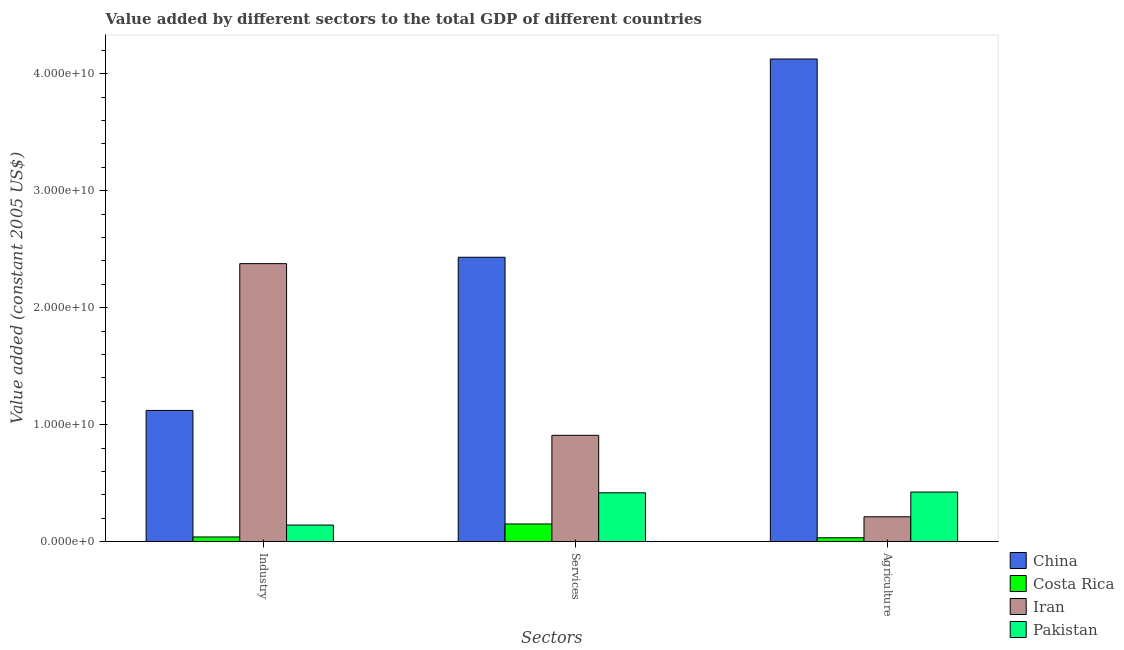How many different coloured bars are there?
Your answer should be compact. 4. How many groups of bars are there?
Offer a very short reply. 3. Are the number of bars on each tick of the X-axis equal?
Provide a succinct answer. Yes. How many bars are there on the 1st tick from the left?
Keep it short and to the point. 4. What is the label of the 1st group of bars from the left?
Offer a terse response. Industry. What is the value added by industrial sector in Costa Rica?
Your answer should be very brief. 3.94e+08. Across all countries, what is the maximum value added by industrial sector?
Make the answer very short. 2.38e+1. Across all countries, what is the minimum value added by agricultural sector?
Keep it short and to the point. 3.24e+08. In which country was the value added by industrial sector minimum?
Make the answer very short. Costa Rica. What is the total value added by services in the graph?
Your answer should be compact. 3.91e+1. What is the difference between the value added by industrial sector in Costa Rica and that in China?
Offer a very short reply. -1.08e+1. What is the difference between the value added by services in Pakistan and the value added by industrial sector in Costa Rica?
Your response must be concise. 3.78e+09. What is the average value added by industrial sector per country?
Provide a short and direct response. 9.20e+09. What is the difference between the value added by services and value added by industrial sector in Pakistan?
Offer a terse response. 2.76e+09. What is the ratio of the value added by services in Costa Rica to that in China?
Give a very brief answer. 0.06. What is the difference between the highest and the second highest value added by agricultural sector?
Provide a short and direct response. 3.70e+1. What is the difference between the highest and the lowest value added by services?
Your response must be concise. 2.28e+1. In how many countries, is the value added by industrial sector greater than the average value added by industrial sector taken over all countries?
Ensure brevity in your answer.  2. What does the 3rd bar from the left in Services represents?
Make the answer very short. Iran. What does the 2nd bar from the right in Industry represents?
Your answer should be compact. Iran. Are all the bars in the graph horizontal?
Ensure brevity in your answer.  No. How many countries are there in the graph?
Offer a very short reply. 4. Are the values on the major ticks of Y-axis written in scientific E-notation?
Your answer should be compact. Yes. Does the graph contain any zero values?
Keep it short and to the point. No. Does the graph contain grids?
Your answer should be very brief. No. How many legend labels are there?
Make the answer very short. 4. What is the title of the graph?
Offer a very short reply. Value added by different sectors to the total GDP of different countries. Does "Poland" appear as one of the legend labels in the graph?
Your answer should be compact. No. What is the label or title of the X-axis?
Keep it short and to the point. Sectors. What is the label or title of the Y-axis?
Keep it short and to the point. Value added (constant 2005 US$). What is the Value added (constant 2005 US$) in China in Industry?
Make the answer very short. 1.12e+1. What is the Value added (constant 2005 US$) in Costa Rica in Industry?
Give a very brief answer. 3.94e+08. What is the Value added (constant 2005 US$) in Iran in Industry?
Give a very brief answer. 2.38e+1. What is the Value added (constant 2005 US$) of Pakistan in Industry?
Make the answer very short. 1.41e+09. What is the Value added (constant 2005 US$) of China in Services?
Provide a succinct answer. 2.43e+1. What is the Value added (constant 2005 US$) of Costa Rica in Services?
Provide a succinct answer. 1.51e+09. What is the Value added (constant 2005 US$) in Iran in Services?
Your answer should be very brief. 9.09e+09. What is the Value added (constant 2005 US$) in Pakistan in Services?
Ensure brevity in your answer.  4.17e+09. What is the Value added (constant 2005 US$) of China in Agriculture?
Your answer should be very brief. 4.13e+1. What is the Value added (constant 2005 US$) of Costa Rica in Agriculture?
Offer a very short reply. 3.24e+08. What is the Value added (constant 2005 US$) in Iran in Agriculture?
Provide a short and direct response. 2.12e+09. What is the Value added (constant 2005 US$) in Pakistan in Agriculture?
Offer a terse response. 4.23e+09. Across all Sectors, what is the maximum Value added (constant 2005 US$) in China?
Give a very brief answer. 4.13e+1. Across all Sectors, what is the maximum Value added (constant 2005 US$) in Costa Rica?
Ensure brevity in your answer.  1.51e+09. Across all Sectors, what is the maximum Value added (constant 2005 US$) of Iran?
Keep it short and to the point. 2.38e+1. Across all Sectors, what is the maximum Value added (constant 2005 US$) of Pakistan?
Keep it short and to the point. 4.23e+09. Across all Sectors, what is the minimum Value added (constant 2005 US$) in China?
Make the answer very short. 1.12e+1. Across all Sectors, what is the minimum Value added (constant 2005 US$) in Costa Rica?
Your answer should be compact. 3.24e+08. Across all Sectors, what is the minimum Value added (constant 2005 US$) of Iran?
Provide a succinct answer. 2.12e+09. Across all Sectors, what is the minimum Value added (constant 2005 US$) of Pakistan?
Provide a short and direct response. 1.41e+09. What is the total Value added (constant 2005 US$) of China in the graph?
Ensure brevity in your answer.  7.68e+1. What is the total Value added (constant 2005 US$) in Costa Rica in the graph?
Give a very brief answer. 2.22e+09. What is the total Value added (constant 2005 US$) in Iran in the graph?
Offer a terse response. 3.50e+1. What is the total Value added (constant 2005 US$) in Pakistan in the graph?
Ensure brevity in your answer.  9.82e+09. What is the difference between the Value added (constant 2005 US$) in China in Industry and that in Services?
Offer a very short reply. -1.31e+1. What is the difference between the Value added (constant 2005 US$) in Costa Rica in Industry and that in Services?
Offer a terse response. -1.11e+09. What is the difference between the Value added (constant 2005 US$) in Iran in Industry and that in Services?
Ensure brevity in your answer.  1.47e+1. What is the difference between the Value added (constant 2005 US$) in Pakistan in Industry and that in Services?
Offer a terse response. -2.76e+09. What is the difference between the Value added (constant 2005 US$) of China in Industry and that in Agriculture?
Give a very brief answer. -3.01e+1. What is the difference between the Value added (constant 2005 US$) of Costa Rica in Industry and that in Agriculture?
Provide a short and direct response. 6.91e+07. What is the difference between the Value added (constant 2005 US$) in Iran in Industry and that in Agriculture?
Give a very brief answer. 2.16e+1. What is the difference between the Value added (constant 2005 US$) of Pakistan in Industry and that in Agriculture?
Make the answer very short. -2.82e+09. What is the difference between the Value added (constant 2005 US$) of China in Services and that in Agriculture?
Your response must be concise. -1.70e+1. What is the difference between the Value added (constant 2005 US$) in Costa Rica in Services and that in Agriculture?
Provide a short and direct response. 1.18e+09. What is the difference between the Value added (constant 2005 US$) of Iran in Services and that in Agriculture?
Offer a terse response. 6.97e+09. What is the difference between the Value added (constant 2005 US$) in Pakistan in Services and that in Agriculture?
Your response must be concise. -6.35e+07. What is the difference between the Value added (constant 2005 US$) in China in Industry and the Value added (constant 2005 US$) in Costa Rica in Services?
Keep it short and to the point. 9.71e+09. What is the difference between the Value added (constant 2005 US$) in China in Industry and the Value added (constant 2005 US$) in Iran in Services?
Provide a succinct answer. 2.13e+09. What is the difference between the Value added (constant 2005 US$) of China in Industry and the Value added (constant 2005 US$) of Pakistan in Services?
Your answer should be compact. 7.04e+09. What is the difference between the Value added (constant 2005 US$) in Costa Rica in Industry and the Value added (constant 2005 US$) in Iran in Services?
Offer a very short reply. -8.69e+09. What is the difference between the Value added (constant 2005 US$) in Costa Rica in Industry and the Value added (constant 2005 US$) in Pakistan in Services?
Your response must be concise. -3.78e+09. What is the difference between the Value added (constant 2005 US$) in Iran in Industry and the Value added (constant 2005 US$) in Pakistan in Services?
Make the answer very short. 1.96e+1. What is the difference between the Value added (constant 2005 US$) of China in Industry and the Value added (constant 2005 US$) of Costa Rica in Agriculture?
Provide a succinct answer. 1.09e+1. What is the difference between the Value added (constant 2005 US$) in China in Industry and the Value added (constant 2005 US$) in Iran in Agriculture?
Offer a terse response. 9.09e+09. What is the difference between the Value added (constant 2005 US$) in China in Industry and the Value added (constant 2005 US$) in Pakistan in Agriculture?
Your answer should be compact. 6.98e+09. What is the difference between the Value added (constant 2005 US$) of Costa Rica in Industry and the Value added (constant 2005 US$) of Iran in Agriculture?
Provide a short and direct response. -1.73e+09. What is the difference between the Value added (constant 2005 US$) of Costa Rica in Industry and the Value added (constant 2005 US$) of Pakistan in Agriculture?
Your answer should be compact. -3.84e+09. What is the difference between the Value added (constant 2005 US$) in Iran in Industry and the Value added (constant 2005 US$) in Pakistan in Agriculture?
Give a very brief answer. 1.95e+1. What is the difference between the Value added (constant 2005 US$) of China in Services and the Value added (constant 2005 US$) of Costa Rica in Agriculture?
Your response must be concise. 2.40e+1. What is the difference between the Value added (constant 2005 US$) of China in Services and the Value added (constant 2005 US$) of Iran in Agriculture?
Your answer should be compact. 2.22e+1. What is the difference between the Value added (constant 2005 US$) in China in Services and the Value added (constant 2005 US$) in Pakistan in Agriculture?
Make the answer very short. 2.01e+1. What is the difference between the Value added (constant 2005 US$) of Costa Rica in Services and the Value added (constant 2005 US$) of Iran in Agriculture?
Provide a succinct answer. -6.14e+08. What is the difference between the Value added (constant 2005 US$) of Costa Rica in Services and the Value added (constant 2005 US$) of Pakistan in Agriculture?
Your answer should be very brief. -2.73e+09. What is the difference between the Value added (constant 2005 US$) in Iran in Services and the Value added (constant 2005 US$) in Pakistan in Agriculture?
Provide a succinct answer. 4.85e+09. What is the average Value added (constant 2005 US$) in China per Sectors?
Your answer should be compact. 2.56e+1. What is the average Value added (constant 2005 US$) in Costa Rica per Sectors?
Provide a short and direct response. 7.41e+08. What is the average Value added (constant 2005 US$) in Iran per Sectors?
Make the answer very short. 1.17e+1. What is the average Value added (constant 2005 US$) of Pakistan per Sectors?
Make the answer very short. 3.27e+09. What is the difference between the Value added (constant 2005 US$) in China and Value added (constant 2005 US$) in Costa Rica in Industry?
Keep it short and to the point. 1.08e+1. What is the difference between the Value added (constant 2005 US$) in China and Value added (constant 2005 US$) in Iran in Industry?
Your answer should be very brief. -1.26e+1. What is the difference between the Value added (constant 2005 US$) in China and Value added (constant 2005 US$) in Pakistan in Industry?
Make the answer very short. 9.80e+09. What is the difference between the Value added (constant 2005 US$) in Costa Rica and Value added (constant 2005 US$) in Iran in Industry?
Offer a very short reply. -2.34e+1. What is the difference between the Value added (constant 2005 US$) in Costa Rica and Value added (constant 2005 US$) in Pakistan in Industry?
Make the answer very short. -1.02e+09. What is the difference between the Value added (constant 2005 US$) of Iran and Value added (constant 2005 US$) of Pakistan in Industry?
Your answer should be very brief. 2.24e+1. What is the difference between the Value added (constant 2005 US$) of China and Value added (constant 2005 US$) of Costa Rica in Services?
Provide a succinct answer. 2.28e+1. What is the difference between the Value added (constant 2005 US$) of China and Value added (constant 2005 US$) of Iran in Services?
Offer a very short reply. 1.52e+1. What is the difference between the Value added (constant 2005 US$) of China and Value added (constant 2005 US$) of Pakistan in Services?
Provide a short and direct response. 2.01e+1. What is the difference between the Value added (constant 2005 US$) of Costa Rica and Value added (constant 2005 US$) of Iran in Services?
Your answer should be compact. -7.58e+09. What is the difference between the Value added (constant 2005 US$) in Costa Rica and Value added (constant 2005 US$) in Pakistan in Services?
Your answer should be compact. -2.67e+09. What is the difference between the Value added (constant 2005 US$) of Iran and Value added (constant 2005 US$) of Pakistan in Services?
Provide a short and direct response. 4.92e+09. What is the difference between the Value added (constant 2005 US$) in China and Value added (constant 2005 US$) in Costa Rica in Agriculture?
Your answer should be compact. 4.09e+1. What is the difference between the Value added (constant 2005 US$) in China and Value added (constant 2005 US$) in Iran in Agriculture?
Offer a very short reply. 3.91e+1. What is the difference between the Value added (constant 2005 US$) in China and Value added (constant 2005 US$) in Pakistan in Agriculture?
Provide a succinct answer. 3.70e+1. What is the difference between the Value added (constant 2005 US$) of Costa Rica and Value added (constant 2005 US$) of Iran in Agriculture?
Offer a terse response. -1.80e+09. What is the difference between the Value added (constant 2005 US$) of Costa Rica and Value added (constant 2005 US$) of Pakistan in Agriculture?
Your response must be concise. -3.91e+09. What is the difference between the Value added (constant 2005 US$) in Iran and Value added (constant 2005 US$) in Pakistan in Agriculture?
Provide a short and direct response. -2.11e+09. What is the ratio of the Value added (constant 2005 US$) in China in Industry to that in Services?
Provide a succinct answer. 0.46. What is the ratio of the Value added (constant 2005 US$) in Costa Rica in Industry to that in Services?
Offer a very short reply. 0.26. What is the ratio of the Value added (constant 2005 US$) in Iran in Industry to that in Services?
Your answer should be very brief. 2.62. What is the ratio of the Value added (constant 2005 US$) in Pakistan in Industry to that in Services?
Keep it short and to the point. 0.34. What is the ratio of the Value added (constant 2005 US$) of China in Industry to that in Agriculture?
Provide a short and direct response. 0.27. What is the ratio of the Value added (constant 2005 US$) in Costa Rica in Industry to that in Agriculture?
Your answer should be compact. 1.21. What is the ratio of the Value added (constant 2005 US$) of Iran in Industry to that in Agriculture?
Provide a succinct answer. 11.21. What is the ratio of the Value added (constant 2005 US$) in Pakistan in Industry to that in Agriculture?
Offer a very short reply. 0.33. What is the ratio of the Value added (constant 2005 US$) in China in Services to that in Agriculture?
Your answer should be very brief. 0.59. What is the ratio of the Value added (constant 2005 US$) of Costa Rica in Services to that in Agriculture?
Provide a succinct answer. 4.64. What is the ratio of the Value added (constant 2005 US$) in Iran in Services to that in Agriculture?
Your answer should be compact. 4.29. What is the ratio of the Value added (constant 2005 US$) in Pakistan in Services to that in Agriculture?
Your answer should be compact. 0.98. What is the difference between the highest and the second highest Value added (constant 2005 US$) in China?
Offer a terse response. 1.70e+1. What is the difference between the highest and the second highest Value added (constant 2005 US$) of Costa Rica?
Ensure brevity in your answer.  1.11e+09. What is the difference between the highest and the second highest Value added (constant 2005 US$) of Iran?
Keep it short and to the point. 1.47e+1. What is the difference between the highest and the second highest Value added (constant 2005 US$) in Pakistan?
Offer a very short reply. 6.35e+07. What is the difference between the highest and the lowest Value added (constant 2005 US$) of China?
Offer a very short reply. 3.01e+1. What is the difference between the highest and the lowest Value added (constant 2005 US$) of Costa Rica?
Keep it short and to the point. 1.18e+09. What is the difference between the highest and the lowest Value added (constant 2005 US$) of Iran?
Make the answer very short. 2.16e+1. What is the difference between the highest and the lowest Value added (constant 2005 US$) in Pakistan?
Offer a very short reply. 2.82e+09. 